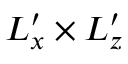Convert formula to latex. <formula><loc_0><loc_0><loc_500><loc_500>L _ { x } ^ { \prime } \times L _ { z } ^ { \prime }</formula> 